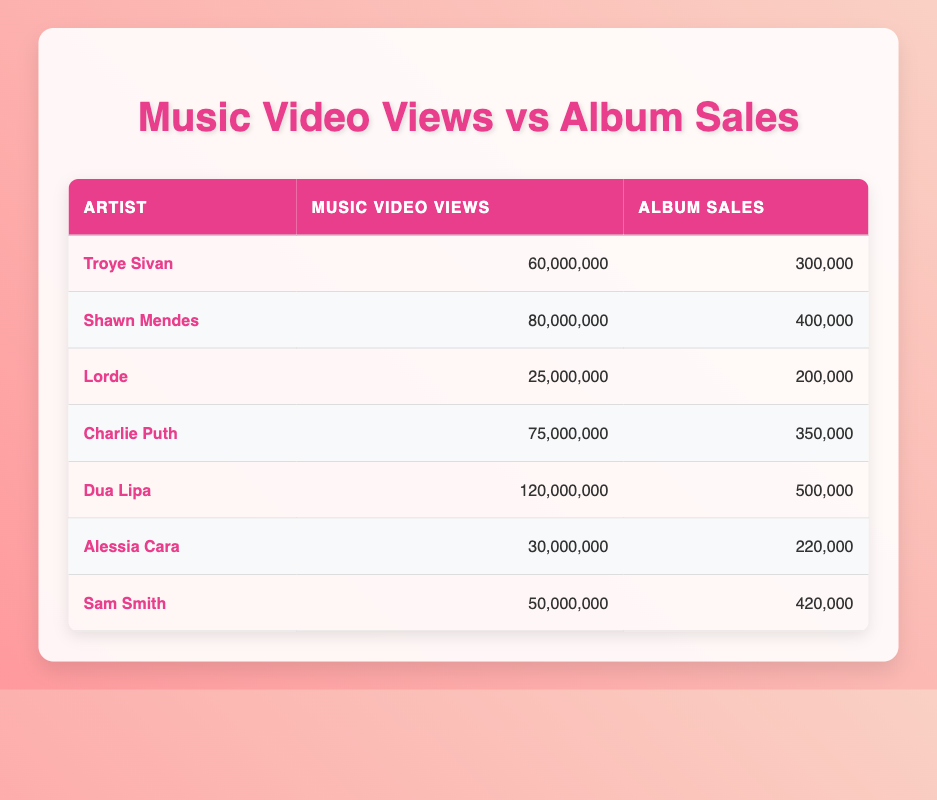What is the total number of album sales for all the artists listed in the table? To find the total album sales, I will add up the album sales for each artist: 300,000 (Troye Sivan) + 400,000 (Shawn Mendes) + 200,000 (Lorde) + 350,000 (Charlie Puth) + 500,000 (Dua Lipa) + 220,000 (Alessia Cara) + 420,000 (Sam Smith) = 2,390,000.
Answer: 2,390,000 Which artist has the highest number of music video views? From the table, I compare the music video views for all the artists. Dua Lipa has 120,000,000 views, which is higher than the rest (the next highest is Shawn Mendes with 80,000,000 views).
Answer: Dua Lipa Is it true that Charlie Puth has more album sales than Sam Smith? Looking at the album sales, Charlie Puth has 350,000 sales while Sam Smith has 420,000. Therefore, it is false that Charlie Puth has more album sales than Sam Smith.
Answer: No What is the average number of music video views among all artists? To calculate the average, I will sum the music video views: 60,000,000 + 80,000,000 + 25,000,000 + 75,000,000 + 120,000,000 + 30,000,000 + 50,000,000 = 440,000,000, then divide by the number of artists (7), which gives me 440,000,000 / 7 = 62,857,143.
Answer: 62,857,143 How many artists have album sales greater than 300,000? From the table, I can count the artists with album sales over 300,000: Shawn Mendes (400,000), Charlie Puth (350,000), Dua Lipa (500,000), and Sam Smith (420,000). There are a total of 4 artists will this sales number.
Answer: 4 What is the difference between the music video views of Troye Sivan and Lorde? I will subtract the music video views of Lorde (25,000,000) from Troye Sivan (60,000,000): 60,000,000 - 25,000,000 = 35,000,000.
Answer: 35,000,000 Did Alessia Cara have more views than Troye Sivan? Comparing the two, Alessia Cara has 30,000,000 views and Troye Sivan has 60,000,000 views. Therefore, it is false that Alessia Cara had more views than Troye Sivan.
Answer: No Which artist has the most album sales considering the number of music video views? I will observe the album sales per 10 million views as follows: Troye Sivan (5 sales per 10 million views), Shawn Mendes (5 sales), Lorde (8 sales), Charlie Puth (4.67 sales), Dua Lipa (4.17 sales), Alessia Cara (7.33 sales), and Sam Smith (8.4 sales). Thus, Lorde and Sam Smith have the most with 8 sales each per 10 million views.
Answer: Lorde and Sam Smith 